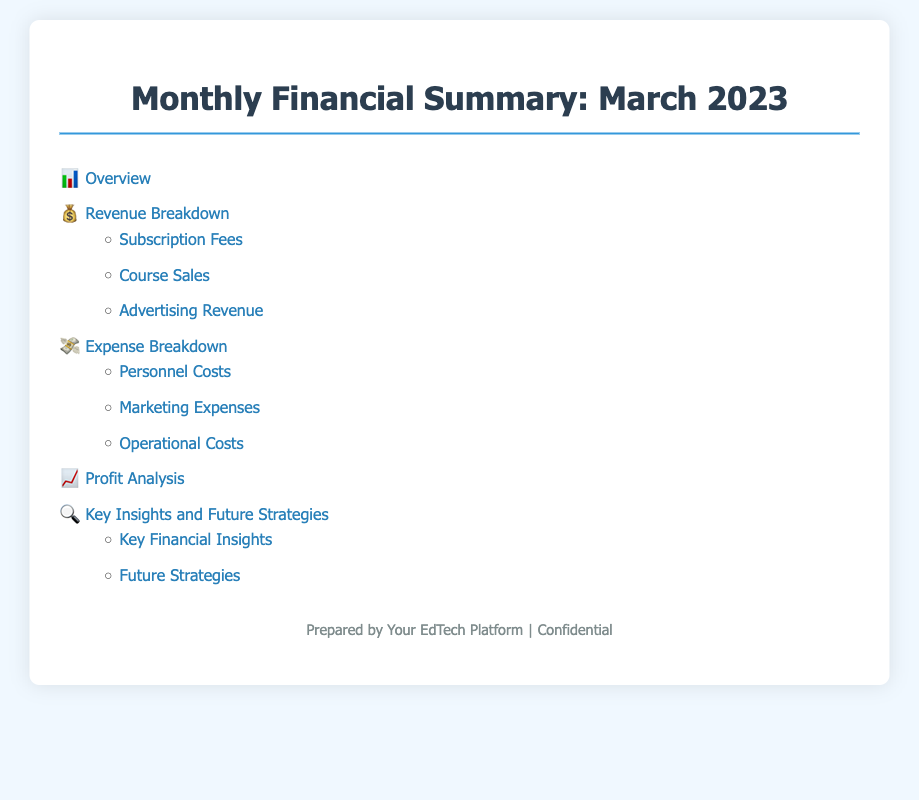what is the title of the document? The title is found in the main heading of the document, which states the purpose and time period of the financial summary.
Answer: Monthly Financial Summary: March 2023 what symbol represents revenue breakdown? The icon preceding the "Revenue Breakdown" section in the index serves as its visual representation.
Answer: 💰 how many sections are under expense breakdown? The expense breakdown section lists three subsections, indicating the categories of expenses.
Answer: 3 what is the first subsection under key insights and future strategies? The first subsection is mentioned directly underneath the main "Key Insights and Future Strategies" section.
Answer: Key Financial Insights which section comes after the expense breakdown? The order of sections in the index shows the flow of information, leading to a logical sequence.
Answer: Profit Analysis how many revenue sources are mentioned? The document lists three distinct revenue sources under the revenue breakdown section.
Answer: 3 